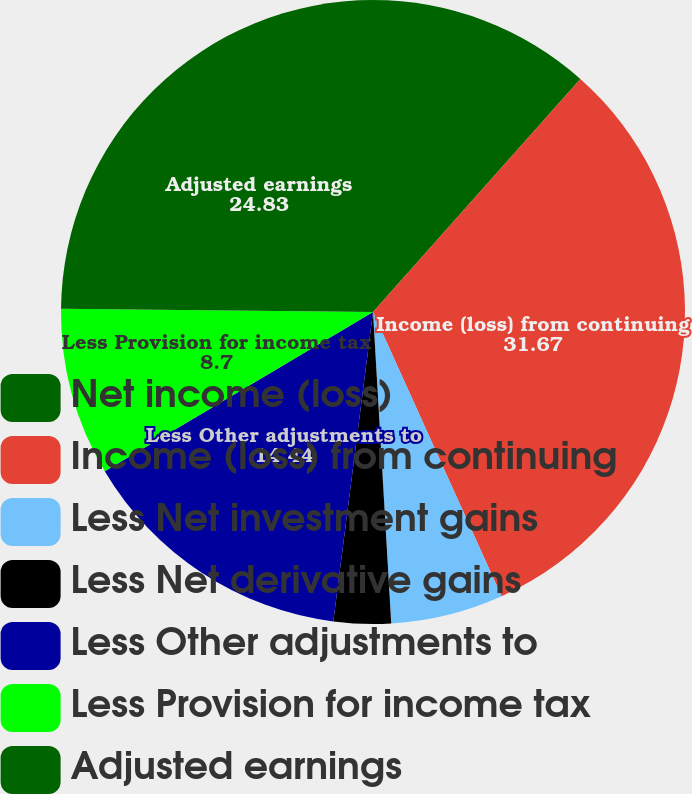Convert chart to OTSL. <chart><loc_0><loc_0><loc_500><loc_500><pie_chart><fcel>Net income (loss)<fcel>Income (loss) from continuing<fcel>Less Net investment gains<fcel>Less Net derivative gains<fcel>Less Other adjustments to<fcel>Less Provision for income tax<fcel>Adjusted earnings<nl><fcel>11.57%<fcel>31.67%<fcel>5.83%<fcel>2.96%<fcel>14.44%<fcel>8.7%<fcel>24.83%<nl></chart> 